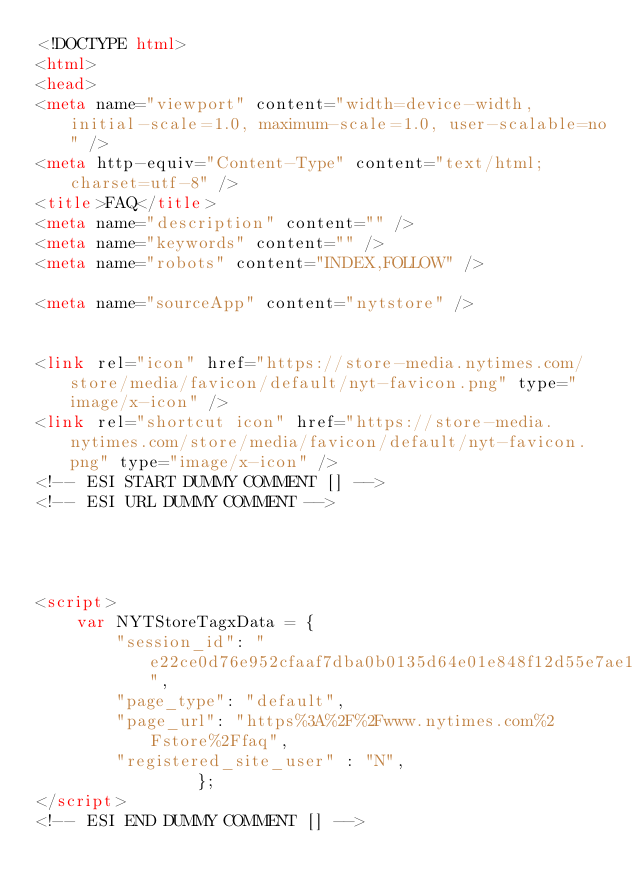Convert code to text. <code><loc_0><loc_0><loc_500><loc_500><_HTML_><!DOCTYPE html>
<html>
<head>
<meta name="viewport" content="width=device-width, initial-scale=1.0, maximum-scale=1.0, user-scalable=no" />
<meta http-equiv="Content-Type" content="text/html; charset=utf-8" />
<title>FAQ</title>
<meta name="description" content="" />
<meta name="keywords" content="" />
<meta name="robots" content="INDEX,FOLLOW" />

<meta name="sourceApp" content="nytstore" />


<link rel="icon" href="https://store-media.nytimes.com/store/media/favicon/default/nyt-favicon.png" type="image/x-icon" />
<link rel="shortcut icon" href="https://store-media.nytimes.com/store/media/favicon/default/nyt-favicon.png" type="image/x-icon" />
<!-- ESI START DUMMY COMMENT [] -->
<!-- ESI URL DUMMY COMMENT -->

 


<script>
    var NYTStoreTagxData = {
        "session_id": "e22ce0d76e952cfaaf7dba0b0135d64e01e848f12d55e7ae1fa3b66bb23b68e5",
        "page_type": "default",
        "page_url": "https%3A%2F%2Fwww.nytimes.com%2Fstore%2Ffaq",
        "registered_site_user" : "N",
                };
</script> 
<!-- ESI END DUMMY COMMENT [] --></code> 